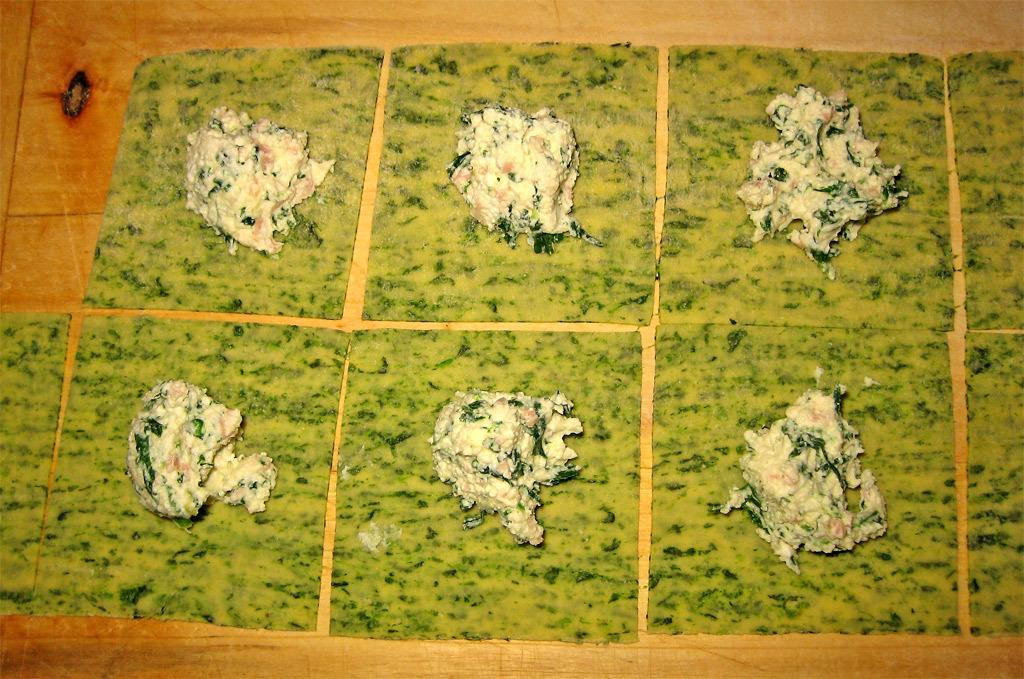What is present in the image that can be consumed? There is food in the image. What type of material can be seen in the background of the image? There is wood visible in the background of the image. What color is the nest in the image? There is no nest present in the image. 